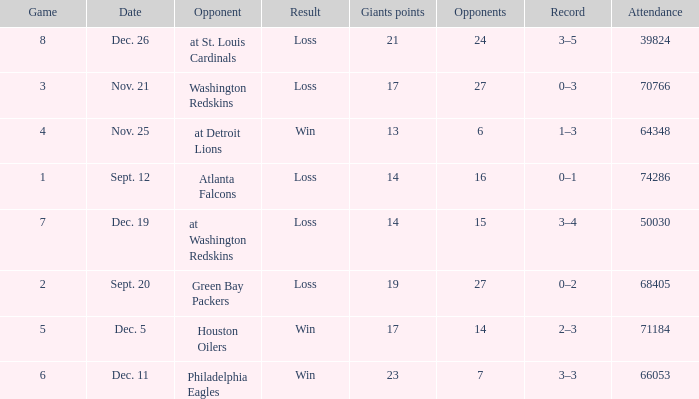What is the record when the opponent is washington redskins? 0–3. 